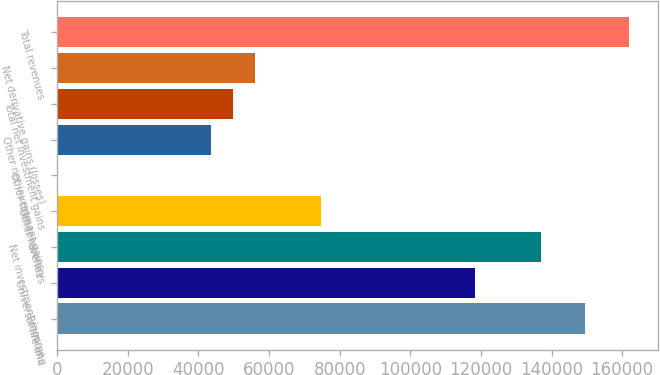<chart> <loc_0><loc_0><loc_500><loc_500><bar_chart><fcel>Premiums<fcel>Universal life and<fcel>Net investment income<fcel>Other revenues<fcel>Other-than-temporary<fcel>Other net investment gains<fcel>Total net investment gains<fcel>Net derivative gains (losses)<fcel>Total revenues<nl><fcel>149538<fcel>118384<fcel>137076<fcel>74769.4<fcel>1<fcel>43615.9<fcel>49846.6<fcel>56077.3<fcel>161999<nl></chart> 